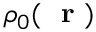Convert formula to latex. <formula><loc_0><loc_0><loc_500><loc_500>\rho _ { 0 } ( r )</formula> 